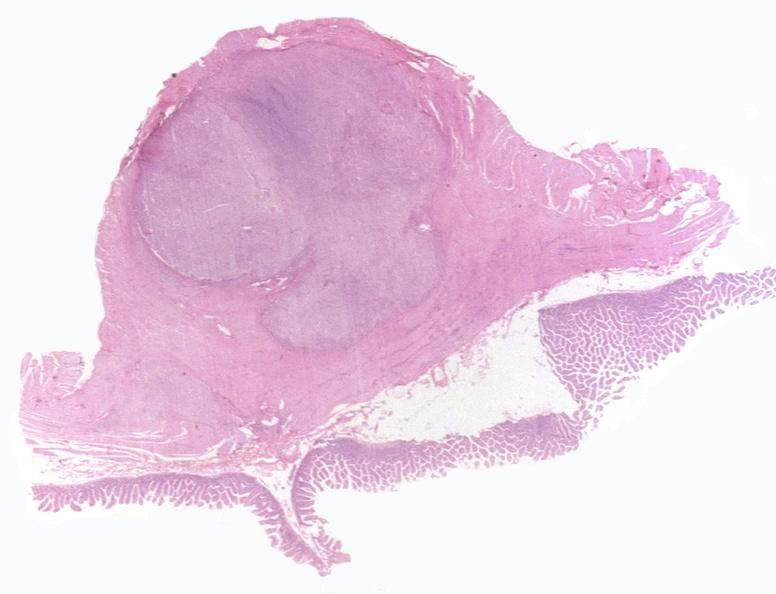s gastrointestinal present?
Answer the question using a single word or phrase. Yes 